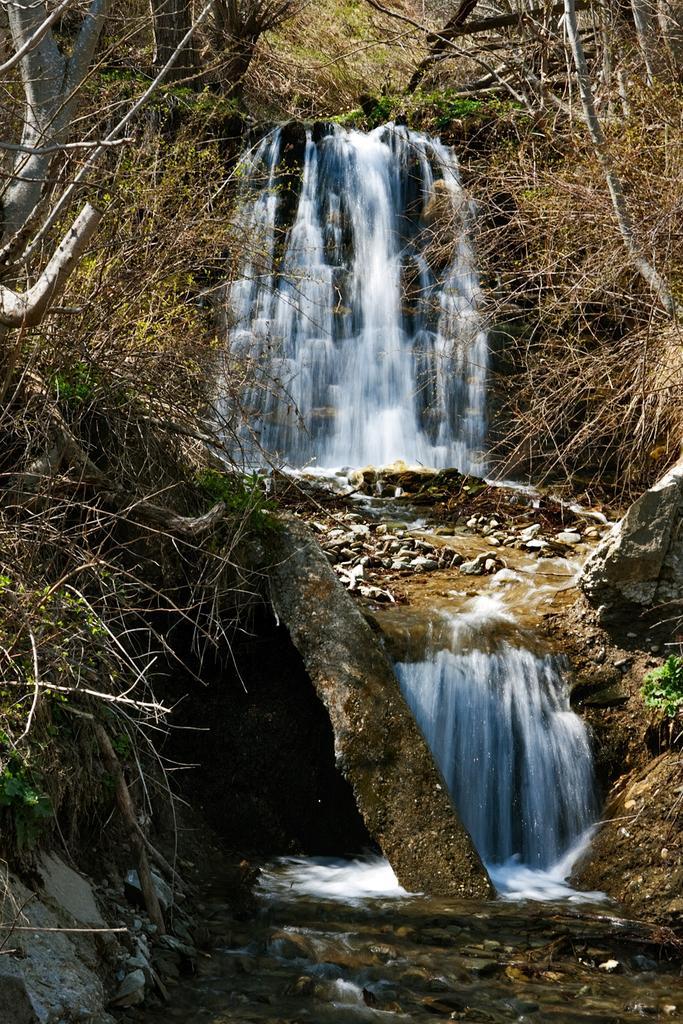Can you describe this image briefly? In this image I can see the waterfall and I can see few dried grass and few grass in green color. 